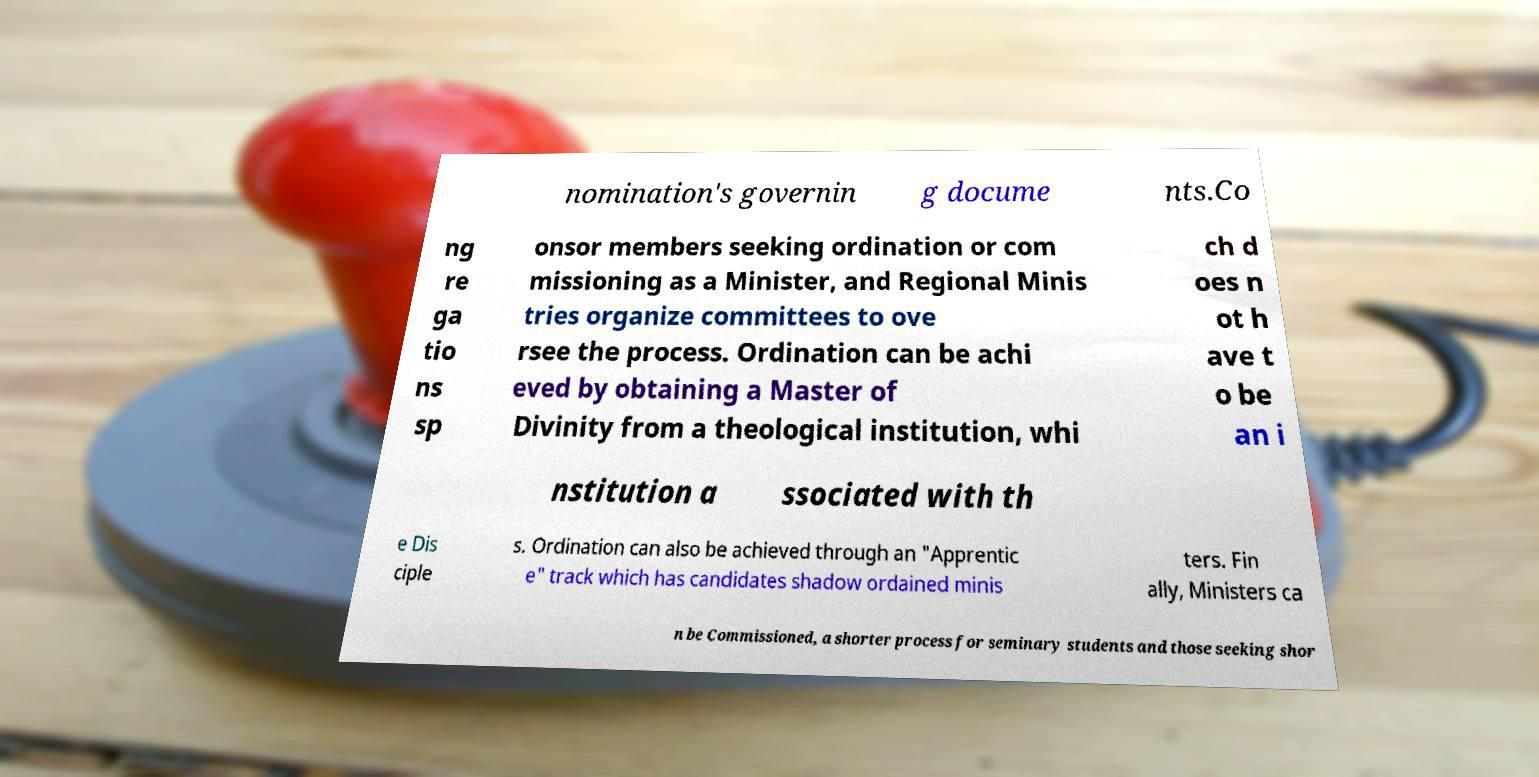There's text embedded in this image that I need extracted. Can you transcribe it verbatim? nomination's governin g docume nts.Co ng re ga tio ns sp onsor members seeking ordination or com missioning as a Minister, and Regional Minis tries organize committees to ove rsee the process. Ordination can be achi eved by obtaining a Master of Divinity from a theological institution, whi ch d oes n ot h ave t o be an i nstitution a ssociated with th e Dis ciple s. Ordination can also be achieved through an "Apprentic e" track which has candidates shadow ordained minis ters. Fin ally, Ministers ca n be Commissioned, a shorter process for seminary students and those seeking shor 